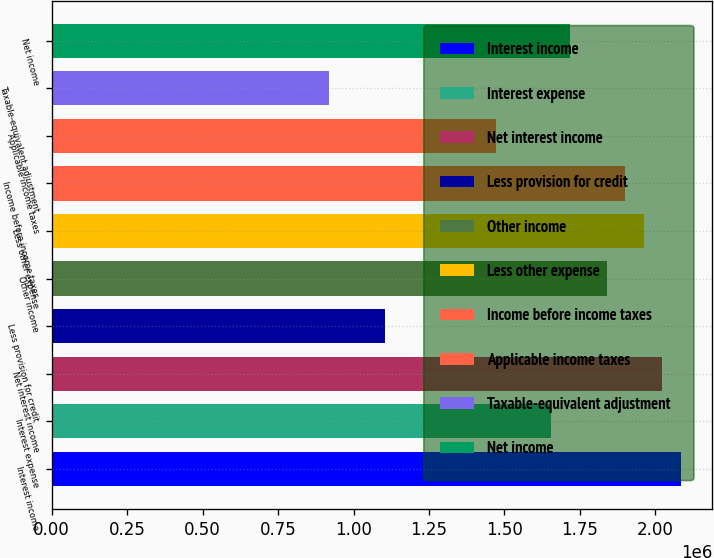Convert chart. <chart><loc_0><loc_0><loc_500><loc_500><bar_chart><fcel>Interest income<fcel>Interest expense<fcel>Net interest income<fcel>Less provision for credit<fcel>Other income<fcel>Less other expense<fcel>Income before income taxes<fcel>Applicable income taxes<fcel>Taxable-equivalent adjustment<fcel>Net income<nl><fcel>2.08424e+06<fcel>1.65513e+06<fcel>2.02294e+06<fcel>1.10342e+06<fcel>1.83904e+06<fcel>1.96164e+06<fcel>1.90034e+06<fcel>1.47123e+06<fcel>919518<fcel>1.71643e+06<nl></chart> 